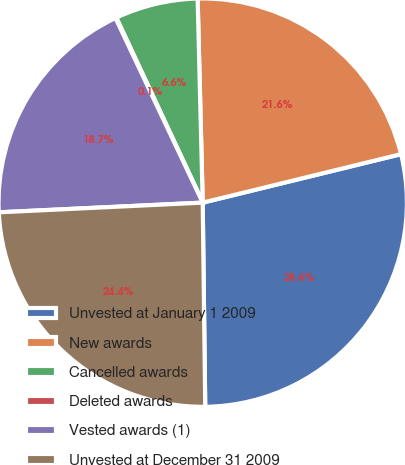Convert chart. <chart><loc_0><loc_0><loc_500><loc_500><pie_chart><fcel>Unvested at January 1 2009<fcel>New awards<fcel>Cancelled awards<fcel>Deleted awards<fcel>Vested awards (1)<fcel>Unvested at December 31 2009<nl><fcel>28.62%<fcel>21.58%<fcel>6.56%<fcel>0.07%<fcel>18.73%<fcel>24.44%<nl></chart> 